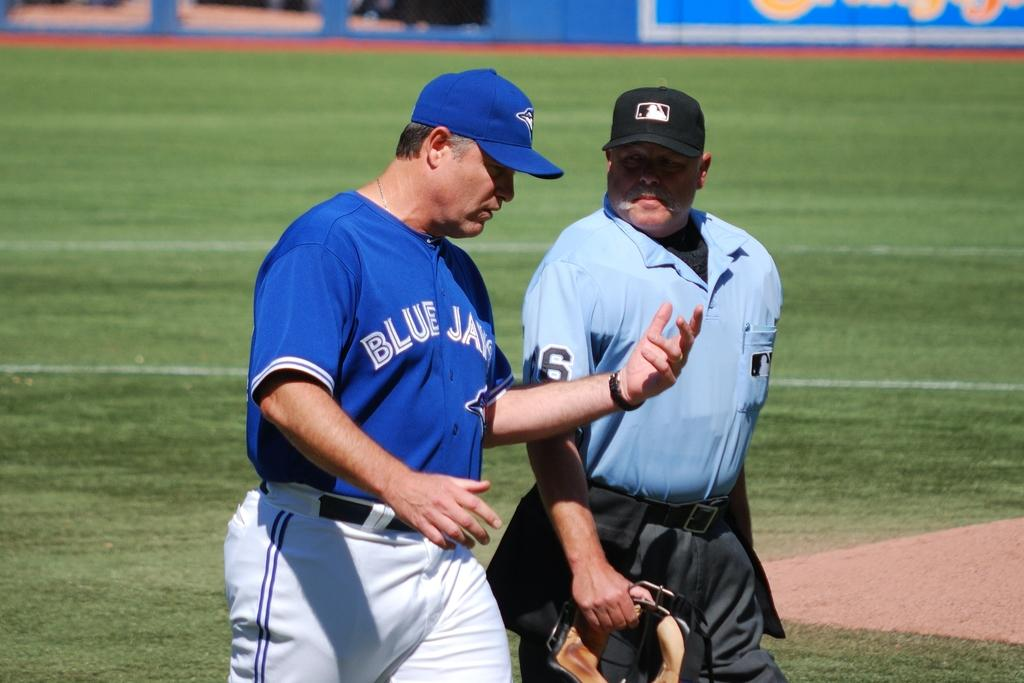<image>
Summarize the visual content of the image. A man in a blue jays uniform talks to an umpire. 